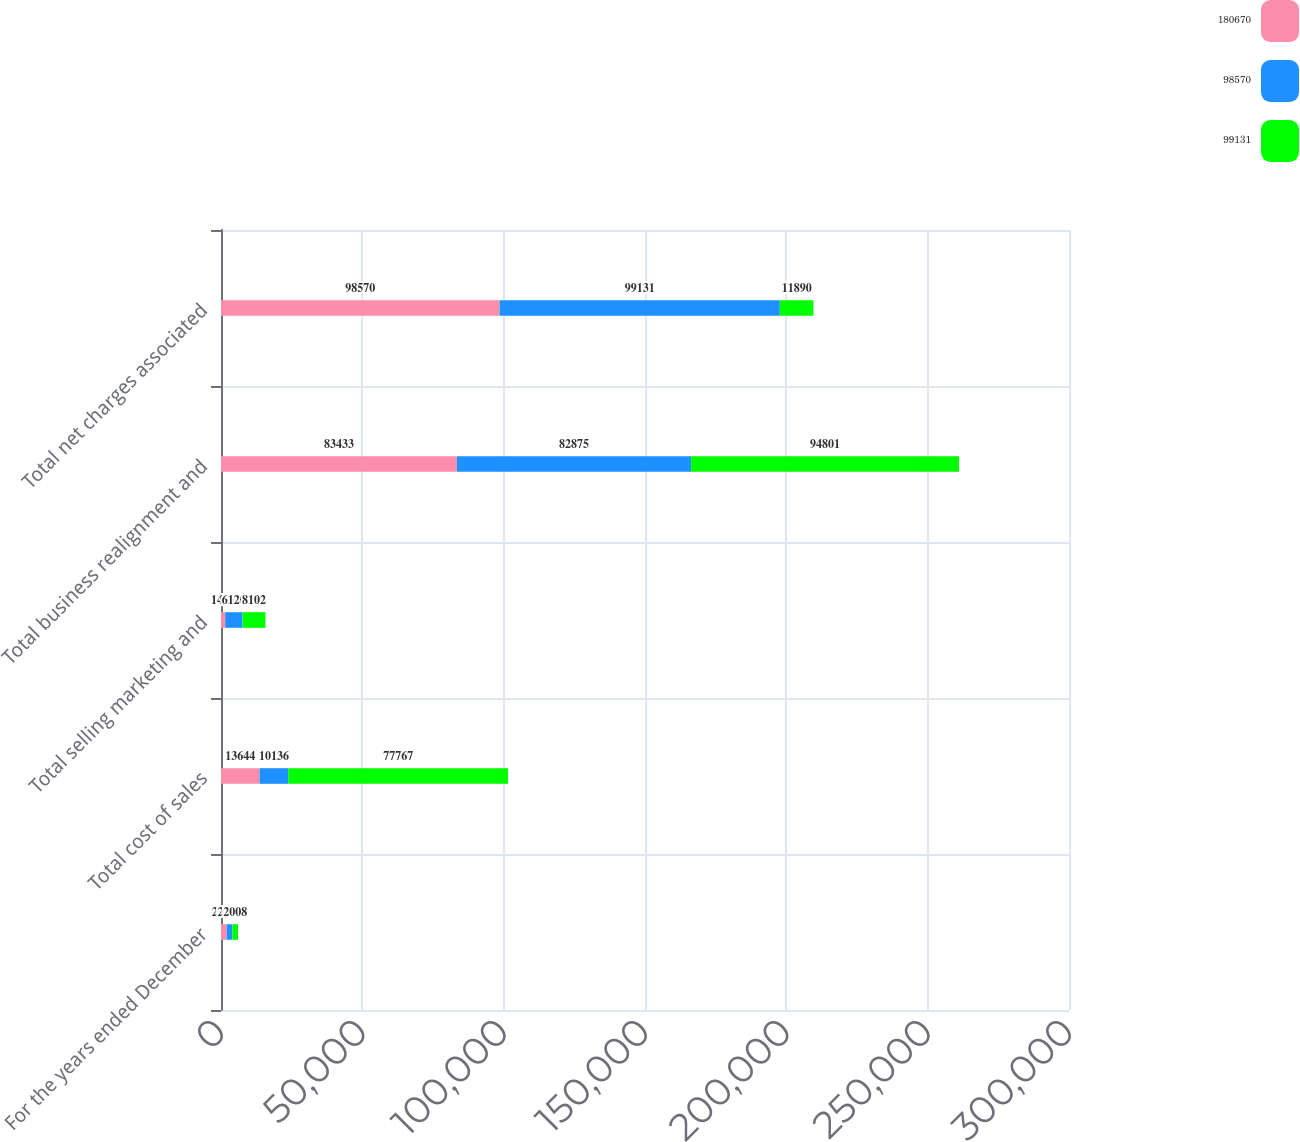Convert chart. <chart><loc_0><loc_0><loc_500><loc_500><stacked_bar_chart><ecel><fcel>For the years ended December<fcel>Total cost of sales<fcel>Total selling marketing and<fcel>Total business realignment and<fcel>Total net charges associated<nl><fcel>180670<fcel>2010<fcel>13644<fcel>1493<fcel>83433<fcel>98570<nl><fcel>98570<fcel>2009<fcel>10136<fcel>6120<fcel>82875<fcel>99131<nl><fcel>99131<fcel>2008<fcel>77767<fcel>8102<fcel>94801<fcel>11890<nl></chart> 